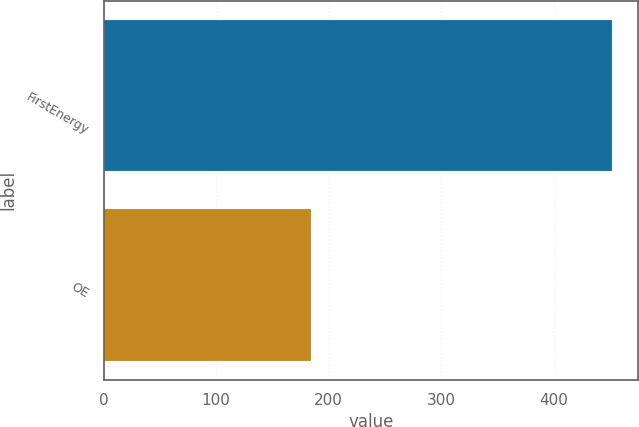Convert chart. <chart><loc_0><loc_0><loc_500><loc_500><bar_chart><fcel>FirstEnergy<fcel>OE<nl><fcel>452<fcel>184<nl></chart> 